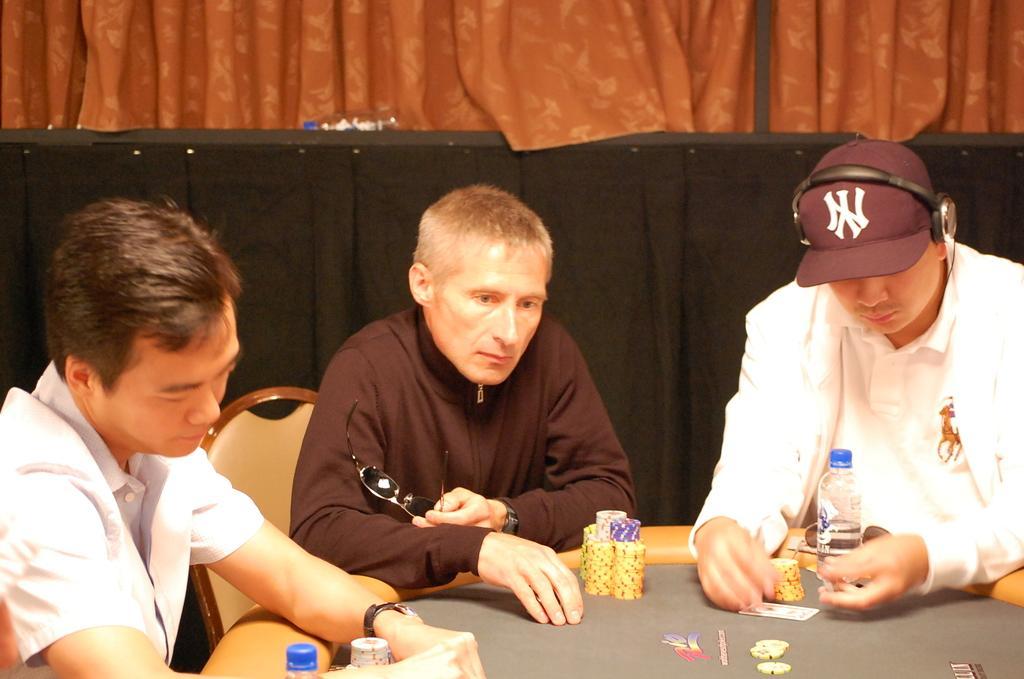Can you describe this image briefly? In this image there are 3 persons sitting in chair near the table and in table there are casino coins , cards ,bottle, and at back ground there is a curtain. 